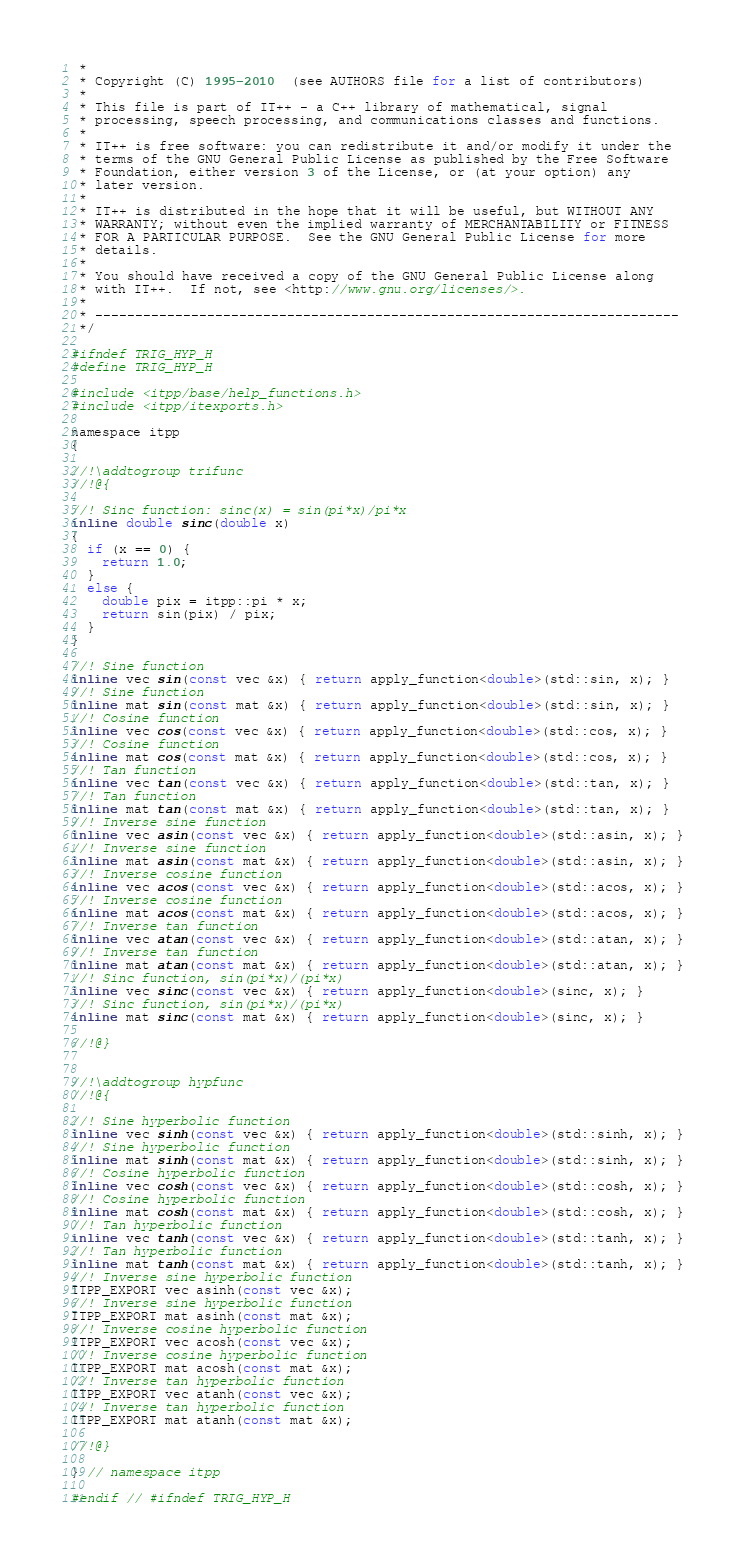Convert code to text. <code><loc_0><loc_0><loc_500><loc_500><_C_> *
 * Copyright (C) 1995-2010  (see AUTHORS file for a list of contributors)
 *
 * This file is part of IT++ - a C++ library of mathematical, signal
 * processing, speech processing, and communications classes and functions.
 *
 * IT++ is free software: you can redistribute it and/or modify it under the
 * terms of the GNU General Public License as published by the Free Software
 * Foundation, either version 3 of the License, or (at your option) any
 * later version.
 *
 * IT++ is distributed in the hope that it will be useful, but WITHOUT ANY
 * WARRANTY; without even the implied warranty of MERCHANTABILITY or FITNESS
 * FOR A PARTICULAR PURPOSE.  See the GNU General Public License for more
 * details.
 *
 * You should have received a copy of the GNU General Public License along
 * with IT++.  If not, see <http://www.gnu.org/licenses/>.
 *
 * -------------------------------------------------------------------------
 */

#ifndef TRIG_HYP_H
#define TRIG_HYP_H

#include <itpp/base/help_functions.h>
#include <itpp/itexports.h>

namespace itpp
{

//!\addtogroup trifunc
//!@{

//! Sinc function: sinc(x) = sin(pi*x)/pi*x
inline double sinc(double x)
{
  if (x == 0) {
    return 1.0;
  }
  else {
    double pix = itpp::pi * x;
    return sin(pix) / pix;
  }
}

//! Sine function
inline vec sin(const vec &x) { return apply_function<double>(std::sin, x); }
//! Sine function
inline mat sin(const mat &x) { return apply_function<double>(std::sin, x); }
//! Cosine function
inline vec cos(const vec &x) { return apply_function<double>(std::cos, x); }
//! Cosine function
inline mat cos(const mat &x) { return apply_function<double>(std::cos, x); }
//! Tan function
inline vec tan(const vec &x) { return apply_function<double>(std::tan, x); }
//! Tan function
inline mat tan(const mat &x) { return apply_function<double>(std::tan, x); }
//! Inverse sine function
inline vec asin(const vec &x) { return apply_function<double>(std::asin, x); }
//! Inverse sine function
inline mat asin(const mat &x) { return apply_function<double>(std::asin, x); }
//! Inverse cosine function
inline vec acos(const vec &x) { return apply_function<double>(std::acos, x); }
//! Inverse cosine function
inline mat acos(const mat &x) { return apply_function<double>(std::acos, x); }
//! Inverse tan function
inline vec atan(const vec &x) { return apply_function<double>(std::atan, x); }
//! Inverse tan function
inline mat atan(const mat &x) { return apply_function<double>(std::atan, x); }
//! Sinc function, sin(pi*x)/(pi*x)
inline vec sinc(const vec &x) { return apply_function<double>(sinc, x); }
//! Sinc function, sin(pi*x)/(pi*x)
inline mat sinc(const mat &x) { return apply_function<double>(sinc, x); }

//!@}


//!\addtogroup hypfunc
//!@{

//! Sine hyperbolic function
inline vec sinh(const vec &x) { return apply_function<double>(std::sinh, x); }
//! Sine hyperbolic function
inline mat sinh(const mat &x) { return apply_function<double>(std::sinh, x); }
//! Cosine hyperbolic function
inline vec cosh(const vec &x) { return apply_function<double>(std::cosh, x); }
//! Cosine hyperbolic function
inline mat cosh(const mat &x) { return apply_function<double>(std::cosh, x); }
//! Tan hyperbolic function
inline vec tanh(const vec &x) { return apply_function<double>(std::tanh, x); }
//! Tan hyperbolic function
inline mat tanh(const mat &x) { return apply_function<double>(std::tanh, x); }
//! Inverse sine hyperbolic function
ITPP_EXPORT vec asinh(const vec &x);
//! Inverse sine hyperbolic function
ITPP_EXPORT mat asinh(const mat &x);
//! Inverse cosine hyperbolic function
ITPP_EXPORT vec acosh(const vec &x);
//! Inverse cosine hyperbolic function
ITPP_EXPORT mat acosh(const mat &x);
//! Inverse tan hyperbolic function
ITPP_EXPORT vec atanh(const vec &x);
//! Inverse tan hyperbolic function
ITPP_EXPORT mat atanh(const mat &x);

//!@}

} // namespace itpp

#endif // #ifndef TRIG_HYP_H
</code> 